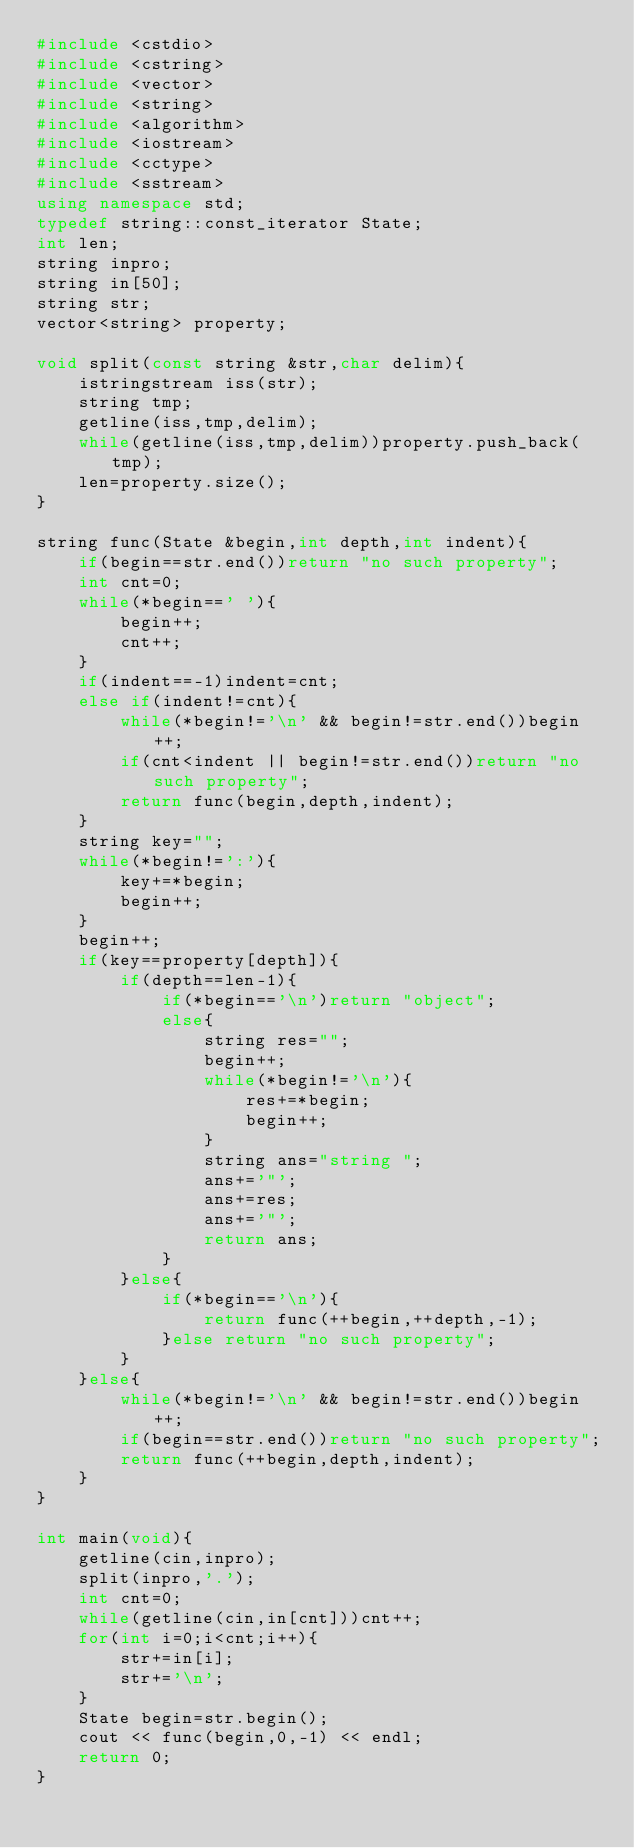<code> <loc_0><loc_0><loc_500><loc_500><_C++_>#include <cstdio>
#include <cstring>
#include <vector>
#include <string>
#include <algorithm>
#include <iostream>
#include <cctype>
#include <sstream>
using namespace std;
typedef string::const_iterator State;
int len;
string inpro;
string in[50];
string str;
vector<string> property;

void split(const string &str,char delim){
	istringstream iss(str);
	string tmp;
	getline(iss,tmp,delim);
	while(getline(iss,tmp,delim))property.push_back(tmp);
	len=property.size();
}

string func(State &begin,int depth,int indent){
	if(begin==str.end())return "no such property";
	int cnt=0;
	while(*begin==' '){
		begin++;
		cnt++;
	}
	if(indent==-1)indent=cnt;
	else if(indent!=cnt){
		while(*begin!='\n' && begin!=str.end())begin++;
		if(cnt<indent || begin!=str.end())return "no such property";
		return func(begin,depth,indent);
	}
	string key="";
	while(*begin!=':'){
		key+=*begin;
		begin++;
	}
	begin++;
	if(key==property[depth]){
		if(depth==len-1){
			if(*begin=='\n')return "object";
			else{
				string res="";
				begin++;
				while(*begin!='\n'){
					res+=*begin;
					begin++;
				}
				string ans="string ";
				ans+='"';
				ans+=res;
				ans+='"';
				return ans;
			}
		}else{
			if(*begin=='\n'){
				return func(++begin,++depth,-1);
			}else return "no such property";
		}
	}else{
		while(*begin!='\n' && begin!=str.end())begin++;
		if(begin==str.end())return "no such property";
		return func(++begin,depth,indent);
	}
}

int main(void){
	getline(cin,inpro);
	split(inpro,'.');
	int cnt=0;
	while(getline(cin,in[cnt]))cnt++;
	for(int i=0;i<cnt;i++){
		str+=in[i];
		str+='\n';
	}
	State begin=str.begin();
	cout << func(begin,0,-1) << endl;
	return 0;
}</code> 